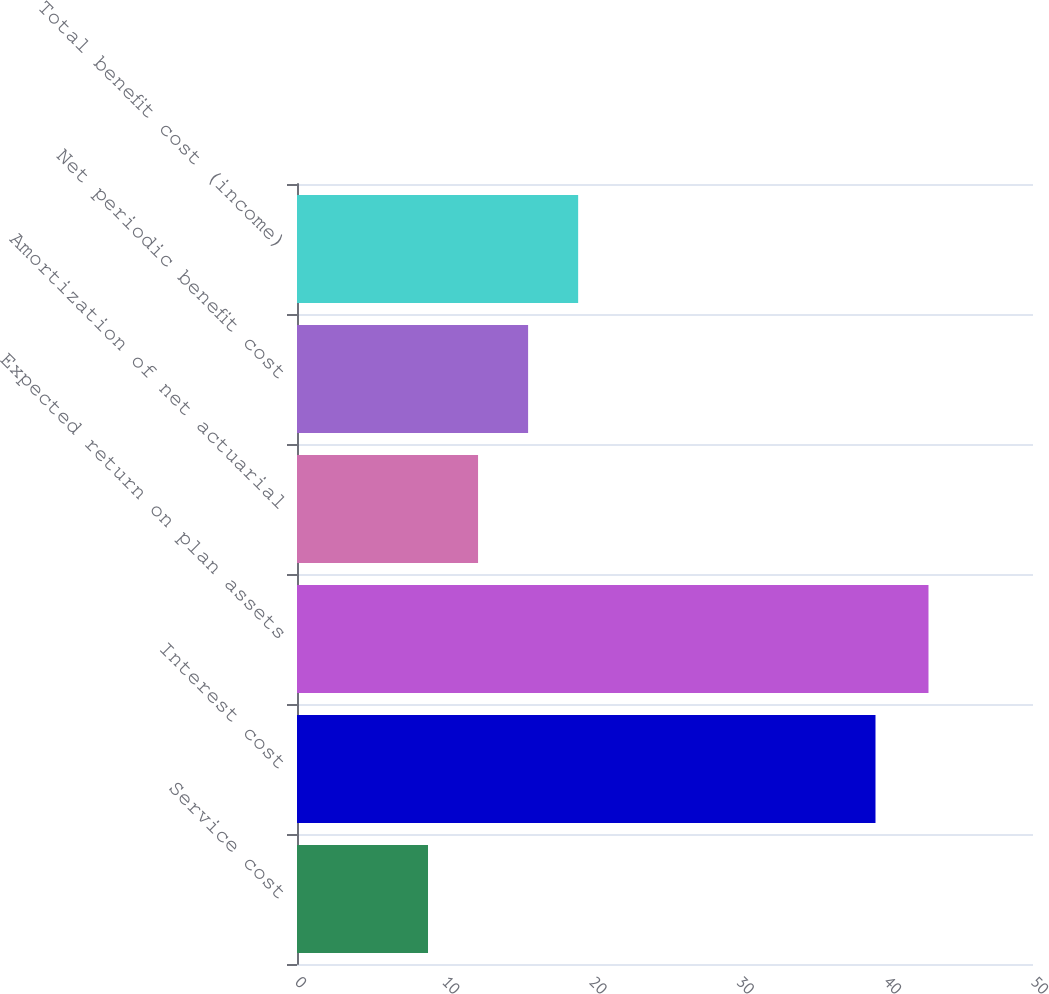Convert chart to OTSL. <chart><loc_0><loc_0><loc_500><loc_500><bar_chart><fcel>Service cost<fcel>Interest cost<fcel>Expected return on plan assets<fcel>Amortization of net actuarial<fcel>Net periodic benefit cost<fcel>Total benefit cost (income)<nl><fcel>8.9<fcel>39.3<fcel>42.9<fcel>12.3<fcel>15.7<fcel>19.1<nl></chart> 